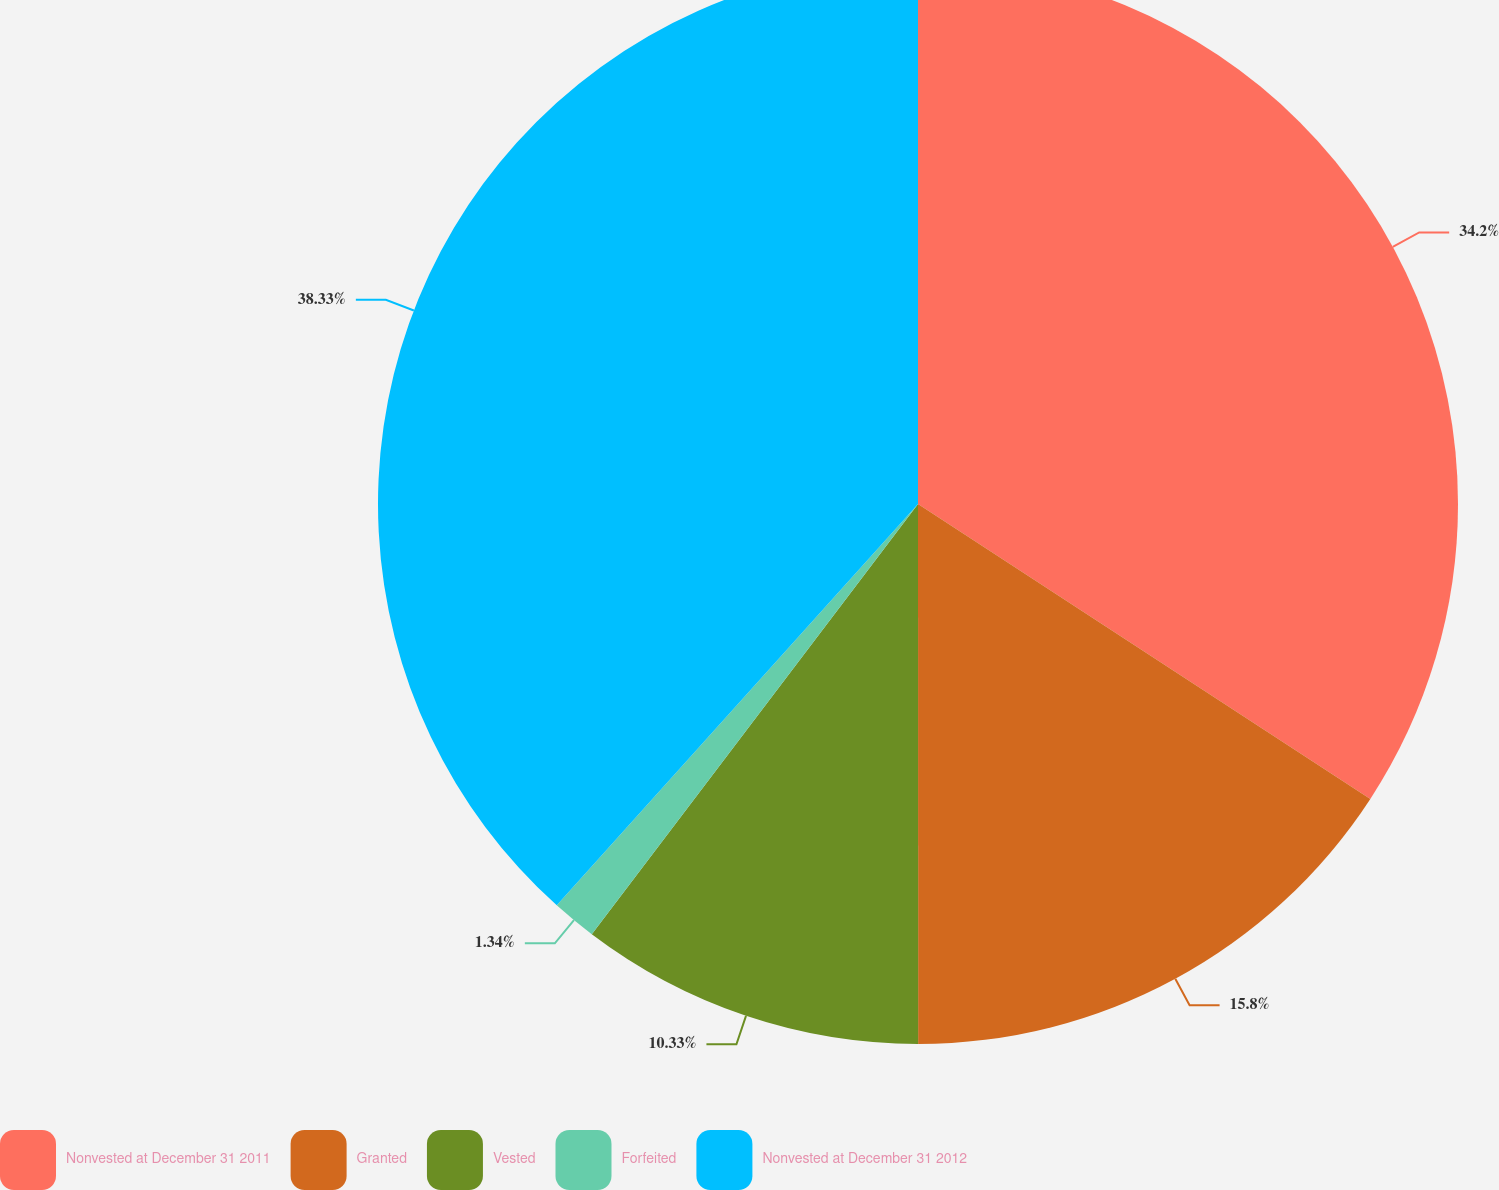Convert chart to OTSL. <chart><loc_0><loc_0><loc_500><loc_500><pie_chart><fcel>Nonvested at December 31 2011<fcel>Granted<fcel>Vested<fcel>Forfeited<fcel>Nonvested at December 31 2012<nl><fcel>34.2%<fcel>15.8%<fcel>10.33%<fcel>1.34%<fcel>38.34%<nl></chart> 